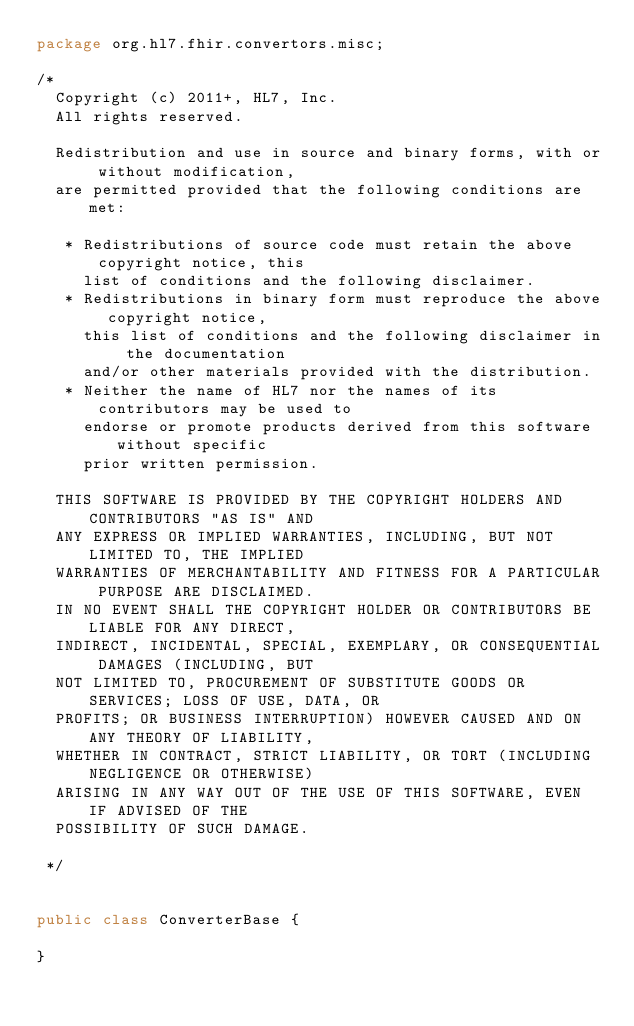Convert code to text. <code><loc_0><loc_0><loc_500><loc_500><_Java_>package org.hl7.fhir.convertors.misc;

/*
  Copyright (c) 2011+, HL7, Inc.
  All rights reserved.
  
  Redistribution and use in source and binary forms, with or without modification, 
  are permitted provided that the following conditions are met:
    
   * Redistributions of source code must retain the above copyright notice, this 
     list of conditions and the following disclaimer.
   * Redistributions in binary form must reproduce the above copyright notice, 
     this list of conditions and the following disclaimer in the documentation 
     and/or other materials provided with the distribution.
   * Neither the name of HL7 nor the names of its contributors may be used to 
     endorse or promote products derived from this software without specific 
     prior written permission.
  
  THIS SOFTWARE IS PROVIDED BY THE COPYRIGHT HOLDERS AND CONTRIBUTORS "AS IS" AND 
  ANY EXPRESS OR IMPLIED WARRANTIES, INCLUDING, BUT NOT LIMITED TO, THE IMPLIED 
  WARRANTIES OF MERCHANTABILITY AND FITNESS FOR A PARTICULAR PURPOSE ARE DISCLAIMED. 
  IN NO EVENT SHALL THE COPYRIGHT HOLDER OR CONTRIBUTORS BE LIABLE FOR ANY DIRECT, 
  INDIRECT, INCIDENTAL, SPECIAL, EXEMPLARY, OR CONSEQUENTIAL DAMAGES (INCLUDING, BUT 
  NOT LIMITED TO, PROCUREMENT OF SUBSTITUTE GOODS OR SERVICES; LOSS OF USE, DATA, OR 
  PROFITS; OR BUSINESS INTERRUPTION) HOWEVER CAUSED AND ON ANY THEORY OF LIABILITY, 
  WHETHER IN CONTRACT, STRICT LIABILITY, OR TORT (INCLUDING NEGLIGENCE OR OTHERWISE) 
  ARISING IN ANY WAY OUT OF THE USE OF THIS SOFTWARE, EVEN IF ADVISED OF THE 
  POSSIBILITY OF SUCH DAMAGE.
  
 */


public class ConverterBase {

}</code> 